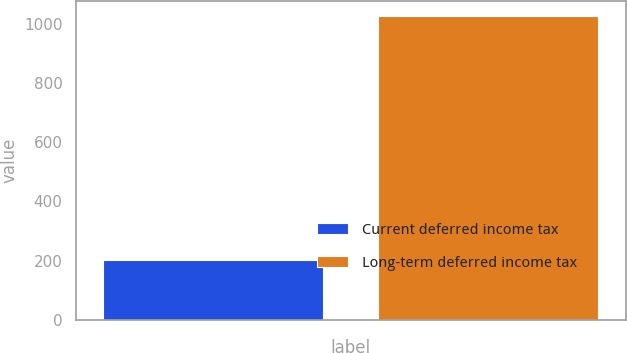Convert chart. <chart><loc_0><loc_0><loc_500><loc_500><bar_chart><fcel>Current deferred income tax<fcel>Long-term deferred income tax<nl><fcel>203.5<fcel>1025<nl></chart> 